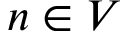<formula> <loc_0><loc_0><loc_500><loc_500>n \in V</formula> 